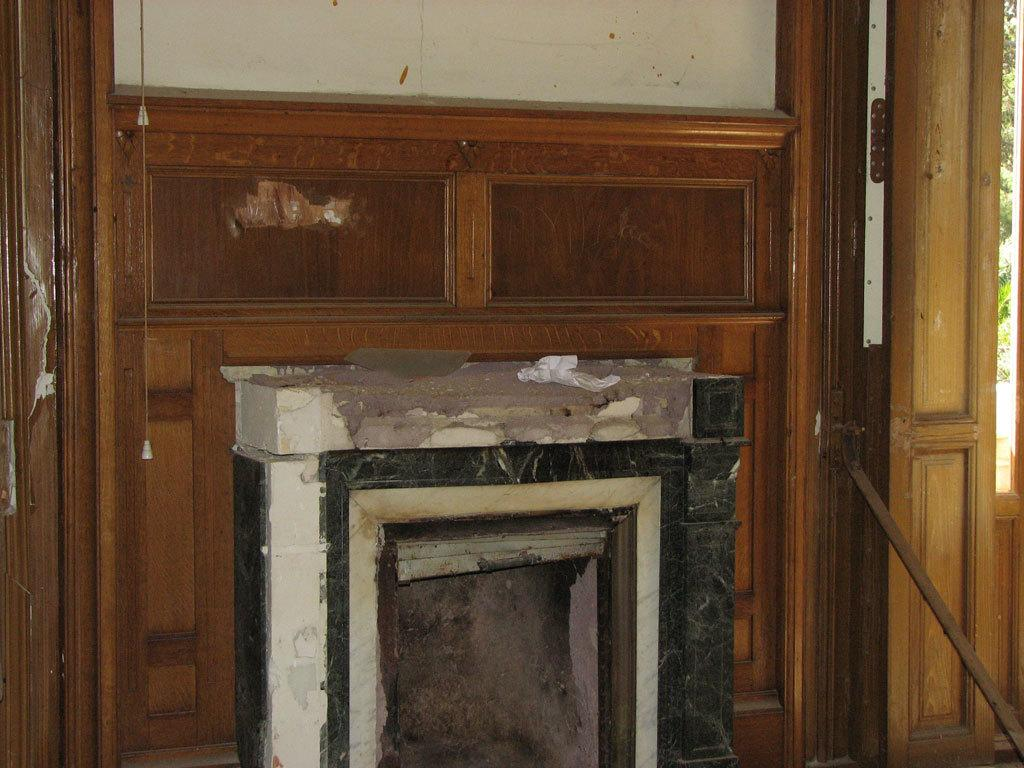What type of feature can be seen in the image? There is a fireplace in the image. Where is the door located in the image? The door is on the right side of the image. What is the color of the door? The door is brown in color. What can be seen behind the door in the image? There is a wall visible in the background of the image. What language is spoken by the fireplace in the image? The fireplace does not speak a language, as it is an inanimate object. 